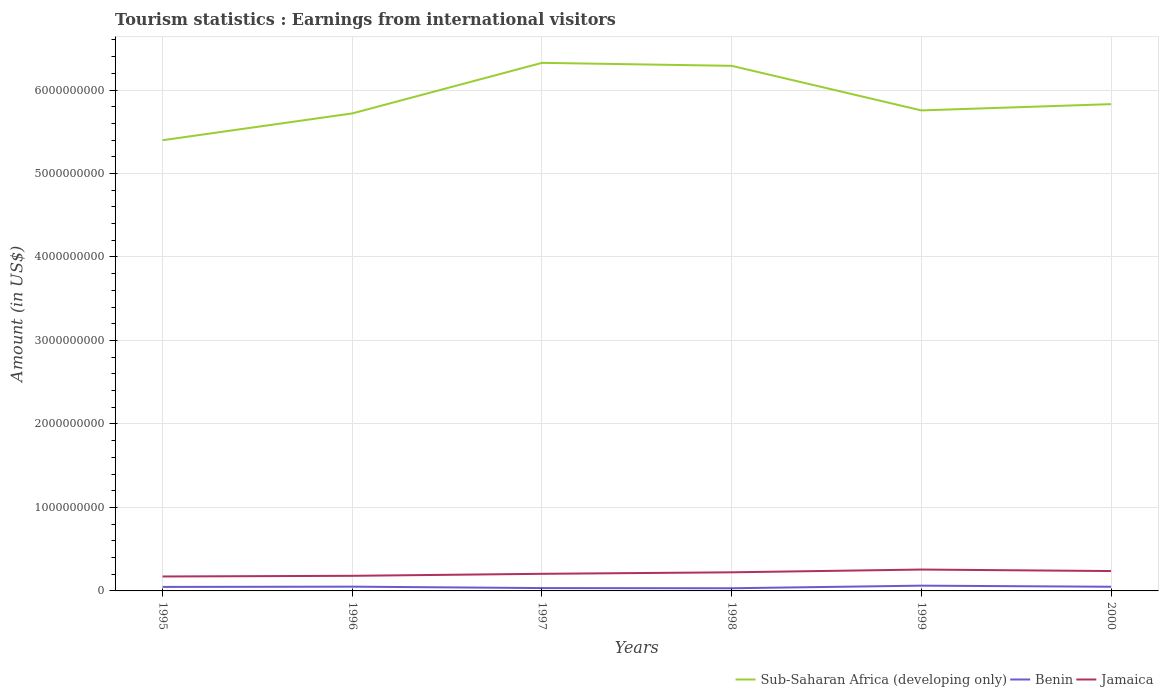Across all years, what is the maximum earnings from international visitors in Sub-Saharan Africa (developing only)?
Make the answer very short. 5.40e+09. What is the total earnings from international visitors in Sub-Saharan Africa (developing only) in the graph?
Provide a succinct answer. -6.06e+08. What is the difference between the highest and the second highest earnings from international visitors in Benin?
Offer a terse response. 3.10e+07. How many years are there in the graph?
Make the answer very short. 6. Does the graph contain grids?
Provide a short and direct response. Yes. What is the title of the graph?
Ensure brevity in your answer.  Tourism statistics : Earnings from international visitors. What is the label or title of the X-axis?
Your response must be concise. Years. What is the Amount (in US$) in Sub-Saharan Africa (developing only) in 1995?
Give a very brief answer. 5.40e+09. What is the Amount (in US$) of Benin in 1995?
Ensure brevity in your answer.  4.80e+07. What is the Amount (in US$) of Jamaica in 1995?
Your answer should be compact. 1.73e+08. What is the Amount (in US$) of Sub-Saharan Africa (developing only) in 1996?
Provide a short and direct response. 5.72e+09. What is the Amount (in US$) in Benin in 1996?
Your answer should be compact. 5.10e+07. What is the Amount (in US$) of Jamaica in 1996?
Your answer should be very brief. 1.81e+08. What is the Amount (in US$) of Sub-Saharan Africa (developing only) in 1997?
Give a very brief answer. 6.33e+09. What is the Amount (in US$) of Benin in 1997?
Your answer should be compact. 3.40e+07. What is the Amount (in US$) of Jamaica in 1997?
Make the answer very short. 2.05e+08. What is the Amount (in US$) of Sub-Saharan Africa (developing only) in 1998?
Your answer should be very brief. 6.29e+09. What is the Amount (in US$) of Benin in 1998?
Your answer should be compact. 3.20e+07. What is the Amount (in US$) of Jamaica in 1998?
Provide a succinct answer. 2.23e+08. What is the Amount (in US$) in Sub-Saharan Africa (developing only) in 1999?
Your answer should be compact. 5.76e+09. What is the Amount (in US$) in Benin in 1999?
Your response must be concise. 6.30e+07. What is the Amount (in US$) of Jamaica in 1999?
Offer a terse response. 2.56e+08. What is the Amount (in US$) of Sub-Saharan Africa (developing only) in 2000?
Offer a terse response. 5.83e+09. What is the Amount (in US$) of Benin in 2000?
Keep it short and to the point. 5.00e+07. What is the Amount (in US$) of Jamaica in 2000?
Provide a short and direct response. 2.38e+08. Across all years, what is the maximum Amount (in US$) in Sub-Saharan Africa (developing only)?
Your response must be concise. 6.33e+09. Across all years, what is the maximum Amount (in US$) in Benin?
Offer a terse response. 6.30e+07. Across all years, what is the maximum Amount (in US$) in Jamaica?
Your response must be concise. 2.56e+08. Across all years, what is the minimum Amount (in US$) in Sub-Saharan Africa (developing only)?
Your answer should be very brief. 5.40e+09. Across all years, what is the minimum Amount (in US$) of Benin?
Your answer should be compact. 3.20e+07. Across all years, what is the minimum Amount (in US$) of Jamaica?
Your answer should be compact. 1.73e+08. What is the total Amount (in US$) in Sub-Saharan Africa (developing only) in the graph?
Offer a very short reply. 3.53e+1. What is the total Amount (in US$) of Benin in the graph?
Give a very brief answer. 2.78e+08. What is the total Amount (in US$) of Jamaica in the graph?
Your response must be concise. 1.28e+09. What is the difference between the Amount (in US$) of Sub-Saharan Africa (developing only) in 1995 and that in 1996?
Offer a very short reply. -3.21e+08. What is the difference between the Amount (in US$) of Benin in 1995 and that in 1996?
Keep it short and to the point. -3.00e+06. What is the difference between the Amount (in US$) in Jamaica in 1995 and that in 1996?
Your response must be concise. -8.00e+06. What is the difference between the Amount (in US$) in Sub-Saharan Africa (developing only) in 1995 and that in 1997?
Make the answer very short. -9.27e+08. What is the difference between the Amount (in US$) of Benin in 1995 and that in 1997?
Offer a terse response. 1.40e+07. What is the difference between the Amount (in US$) of Jamaica in 1995 and that in 1997?
Your response must be concise. -3.20e+07. What is the difference between the Amount (in US$) of Sub-Saharan Africa (developing only) in 1995 and that in 1998?
Give a very brief answer. -8.91e+08. What is the difference between the Amount (in US$) in Benin in 1995 and that in 1998?
Keep it short and to the point. 1.60e+07. What is the difference between the Amount (in US$) in Jamaica in 1995 and that in 1998?
Give a very brief answer. -5.00e+07. What is the difference between the Amount (in US$) in Sub-Saharan Africa (developing only) in 1995 and that in 1999?
Provide a succinct answer. -3.57e+08. What is the difference between the Amount (in US$) of Benin in 1995 and that in 1999?
Make the answer very short. -1.50e+07. What is the difference between the Amount (in US$) in Jamaica in 1995 and that in 1999?
Your answer should be compact. -8.30e+07. What is the difference between the Amount (in US$) in Sub-Saharan Africa (developing only) in 1995 and that in 2000?
Your answer should be compact. -4.32e+08. What is the difference between the Amount (in US$) of Benin in 1995 and that in 2000?
Ensure brevity in your answer.  -2.00e+06. What is the difference between the Amount (in US$) of Jamaica in 1995 and that in 2000?
Keep it short and to the point. -6.50e+07. What is the difference between the Amount (in US$) of Sub-Saharan Africa (developing only) in 1996 and that in 1997?
Your answer should be compact. -6.06e+08. What is the difference between the Amount (in US$) in Benin in 1996 and that in 1997?
Ensure brevity in your answer.  1.70e+07. What is the difference between the Amount (in US$) of Jamaica in 1996 and that in 1997?
Your answer should be compact. -2.40e+07. What is the difference between the Amount (in US$) of Sub-Saharan Africa (developing only) in 1996 and that in 1998?
Give a very brief answer. -5.70e+08. What is the difference between the Amount (in US$) of Benin in 1996 and that in 1998?
Give a very brief answer. 1.90e+07. What is the difference between the Amount (in US$) in Jamaica in 1996 and that in 1998?
Offer a terse response. -4.20e+07. What is the difference between the Amount (in US$) in Sub-Saharan Africa (developing only) in 1996 and that in 1999?
Your answer should be compact. -3.59e+07. What is the difference between the Amount (in US$) of Benin in 1996 and that in 1999?
Provide a succinct answer. -1.20e+07. What is the difference between the Amount (in US$) of Jamaica in 1996 and that in 1999?
Your answer should be compact. -7.50e+07. What is the difference between the Amount (in US$) in Sub-Saharan Africa (developing only) in 1996 and that in 2000?
Give a very brief answer. -1.11e+08. What is the difference between the Amount (in US$) of Benin in 1996 and that in 2000?
Offer a terse response. 1.00e+06. What is the difference between the Amount (in US$) of Jamaica in 1996 and that in 2000?
Offer a very short reply. -5.70e+07. What is the difference between the Amount (in US$) in Sub-Saharan Africa (developing only) in 1997 and that in 1998?
Provide a succinct answer. 3.57e+07. What is the difference between the Amount (in US$) of Benin in 1997 and that in 1998?
Ensure brevity in your answer.  2.00e+06. What is the difference between the Amount (in US$) of Jamaica in 1997 and that in 1998?
Give a very brief answer. -1.80e+07. What is the difference between the Amount (in US$) of Sub-Saharan Africa (developing only) in 1997 and that in 1999?
Offer a terse response. 5.70e+08. What is the difference between the Amount (in US$) in Benin in 1997 and that in 1999?
Offer a terse response. -2.90e+07. What is the difference between the Amount (in US$) in Jamaica in 1997 and that in 1999?
Keep it short and to the point. -5.10e+07. What is the difference between the Amount (in US$) of Sub-Saharan Africa (developing only) in 1997 and that in 2000?
Your response must be concise. 4.95e+08. What is the difference between the Amount (in US$) in Benin in 1997 and that in 2000?
Give a very brief answer. -1.60e+07. What is the difference between the Amount (in US$) of Jamaica in 1997 and that in 2000?
Offer a terse response. -3.30e+07. What is the difference between the Amount (in US$) of Sub-Saharan Africa (developing only) in 1998 and that in 1999?
Offer a terse response. 5.34e+08. What is the difference between the Amount (in US$) in Benin in 1998 and that in 1999?
Provide a short and direct response. -3.10e+07. What is the difference between the Amount (in US$) in Jamaica in 1998 and that in 1999?
Your answer should be very brief. -3.30e+07. What is the difference between the Amount (in US$) in Sub-Saharan Africa (developing only) in 1998 and that in 2000?
Keep it short and to the point. 4.59e+08. What is the difference between the Amount (in US$) of Benin in 1998 and that in 2000?
Offer a very short reply. -1.80e+07. What is the difference between the Amount (in US$) in Jamaica in 1998 and that in 2000?
Keep it short and to the point. -1.50e+07. What is the difference between the Amount (in US$) in Sub-Saharan Africa (developing only) in 1999 and that in 2000?
Make the answer very short. -7.52e+07. What is the difference between the Amount (in US$) in Benin in 1999 and that in 2000?
Keep it short and to the point. 1.30e+07. What is the difference between the Amount (in US$) in Jamaica in 1999 and that in 2000?
Provide a succinct answer. 1.80e+07. What is the difference between the Amount (in US$) of Sub-Saharan Africa (developing only) in 1995 and the Amount (in US$) of Benin in 1996?
Offer a very short reply. 5.35e+09. What is the difference between the Amount (in US$) of Sub-Saharan Africa (developing only) in 1995 and the Amount (in US$) of Jamaica in 1996?
Give a very brief answer. 5.22e+09. What is the difference between the Amount (in US$) in Benin in 1995 and the Amount (in US$) in Jamaica in 1996?
Your answer should be very brief. -1.33e+08. What is the difference between the Amount (in US$) in Sub-Saharan Africa (developing only) in 1995 and the Amount (in US$) in Benin in 1997?
Your response must be concise. 5.36e+09. What is the difference between the Amount (in US$) in Sub-Saharan Africa (developing only) in 1995 and the Amount (in US$) in Jamaica in 1997?
Offer a terse response. 5.19e+09. What is the difference between the Amount (in US$) of Benin in 1995 and the Amount (in US$) of Jamaica in 1997?
Your answer should be compact. -1.57e+08. What is the difference between the Amount (in US$) in Sub-Saharan Africa (developing only) in 1995 and the Amount (in US$) in Benin in 1998?
Your response must be concise. 5.37e+09. What is the difference between the Amount (in US$) in Sub-Saharan Africa (developing only) in 1995 and the Amount (in US$) in Jamaica in 1998?
Your answer should be compact. 5.18e+09. What is the difference between the Amount (in US$) in Benin in 1995 and the Amount (in US$) in Jamaica in 1998?
Provide a succinct answer. -1.75e+08. What is the difference between the Amount (in US$) in Sub-Saharan Africa (developing only) in 1995 and the Amount (in US$) in Benin in 1999?
Offer a terse response. 5.34e+09. What is the difference between the Amount (in US$) of Sub-Saharan Africa (developing only) in 1995 and the Amount (in US$) of Jamaica in 1999?
Keep it short and to the point. 5.14e+09. What is the difference between the Amount (in US$) in Benin in 1995 and the Amount (in US$) in Jamaica in 1999?
Your response must be concise. -2.08e+08. What is the difference between the Amount (in US$) of Sub-Saharan Africa (developing only) in 1995 and the Amount (in US$) of Benin in 2000?
Offer a terse response. 5.35e+09. What is the difference between the Amount (in US$) of Sub-Saharan Africa (developing only) in 1995 and the Amount (in US$) of Jamaica in 2000?
Make the answer very short. 5.16e+09. What is the difference between the Amount (in US$) of Benin in 1995 and the Amount (in US$) of Jamaica in 2000?
Your response must be concise. -1.90e+08. What is the difference between the Amount (in US$) in Sub-Saharan Africa (developing only) in 1996 and the Amount (in US$) in Benin in 1997?
Give a very brief answer. 5.69e+09. What is the difference between the Amount (in US$) of Sub-Saharan Africa (developing only) in 1996 and the Amount (in US$) of Jamaica in 1997?
Offer a terse response. 5.51e+09. What is the difference between the Amount (in US$) in Benin in 1996 and the Amount (in US$) in Jamaica in 1997?
Offer a very short reply. -1.54e+08. What is the difference between the Amount (in US$) of Sub-Saharan Africa (developing only) in 1996 and the Amount (in US$) of Benin in 1998?
Make the answer very short. 5.69e+09. What is the difference between the Amount (in US$) in Sub-Saharan Africa (developing only) in 1996 and the Amount (in US$) in Jamaica in 1998?
Give a very brief answer. 5.50e+09. What is the difference between the Amount (in US$) in Benin in 1996 and the Amount (in US$) in Jamaica in 1998?
Your answer should be very brief. -1.72e+08. What is the difference between the Amount (in US$) in Sub-Saharan Africa (developing only) in 1996 and the Amount (in US$) in Benin in 1999?
Your response must be concise. 5.66e+09. What is the difference between the Amount (in US$) of Sub-Saharan Africa (developing only) in 1996 and the Amount (in US$) of Jamaica in 1999?
Your answer should be compact. 5.46e+09. What is the difference between the Amount (in US$) in Benin in 1996 and the Amount (in US$) in Jamaica in 1999?
Offer a very short reply. -2.05e+08. What is the difference between the Amount (in US$) in Sub-Saharan Africa (developing only) in 1996 and the Amount (in US$) in Benin in 2000?
Your answer should be compact. 5.67e+09. What is the difference between the Amount (in US$) of Sub-Saharan Africa (developing only) in 1996 and the Amount (in US$) of Jamaica in 2000?
Your answer should be compact. 5.48e+09. What is the difference between the Amount (in US$) in Benin in 1996 and the Amount (in US$) in Jamaica in 2000?
Your answer should be very brief. -1.87e+08. What is the difference between the Amount (in US$) in Sub-Saharan Africa (developing only) in 1997 and the Amount (in US$) in Benin in 1998?
Give a very brief answer. 6.29e+09. What is the difference between the Amount (in US$) of Sub-Saharan Africa (developing only) in 1997 and the Amount (in US$) of Jamaica in 1998?
Ensure brevity in your answer.  6.10e+09. What is the difference between the Amount (in US$) in Benin in 1997 and the Amount (in US$) in Jamaica in 1998?
Ensure brevity in your answer.  -1.89e+08. What is the difference between the Amount (in US$) in Sub-Saharan Africa (developing only) in 1997 and the Amount (in US$) in Benin in 1999?
Provide a succinct answer. 6.26e+09. What is the difference between the Amount (in US$) in Sub-Saharan Africa (developing only) in 1997 and the Amount (in US$) in Jamaica in 1999?
Ensure brevity in your answer.  6.07e+09. What is the difference between the Amount (in US$) of Benin in 1997 and the Amount (in US$) of Jamaica in 1999?
Keep it short and to the point. -2.22e+08. What is the difference between the Amount (in US$) in Sub-Saharan Africa (developing only) in 1997 and the Amount (in US$) in Benin in 2000?
Your response must be concise. 6.28e+09. What is the difference between the Amount (in US$) in Sub-Saharan Africa (developing only) in 1997 and the Amount (in US$) in Jamaica in 2000?
Your answer should be compact. 6.09e+09. What is the difference between the Amount (in US$) in Benin in 1997 and the Amount (in US$) in Jamaica in 2000?
Give a very brief answer. -2.04e+08. What is the difference between the Amount (in US$) of Sub-Saharan Africa (developing only) in 1998 and the Amount (in US$) of Benin in 1999?
Keep it short and to the point. 6.23e+09. What is the difference between the Amount (in US$) of Sub-Saharan Africa (developing only) in 1998 and the Amount (in US$) of Jamaica in 1999?
Provide a short and direct response. 6.03e+09. What is the difference between the Amount (in US$) of Benin in 1998 and the Amount (in US$) of Jamaica in 1999?
Keep it short and to the point. -2.24e+08. What is the difference between the Amount (in US$) of Sub-Saharan Africa (developing only) in 1998 and the Amount (in US$) of Benin in 2000?
Offer a terse response. 6.24e+09. What is the difference between the Amount (in US$) in Sub-Saharan Africa (developing only) in 1998 and the Amount (in US$) in Jamaica in 2000?
Make the answer very short. 6.05e+09. What is the difference between the Amount (in US$) in Benin in 1998 and the Amount (in US$) in Jamaica in 2000?
Your answer should be compact. -2.06e+08. What is the difference between the Amount (in US$) in Sub-Saharan Africa (developing only) in 1999 and the Amount (in US$) in Benin in 2000?
Offer a very short reply. 5.71e+09. What is the difference between the Amount (in US$) of Sub-Saharan Africa (developing only) in 1999 and the Amount (in US$) of Jamaica in 2000?
Keep it short and to the point. 5.52e+09. What is the difference between the Amount (in US$) in Benin in 1999 and the Amount (in US$) in Jamaica in 2000?
Offer a very short reply. -1.75e+08. What is the average Amount (in US$) in Sub-Saharan Africa (developing only) per year?
Give a very brief answer. 5.89e+09. What is the average Amount (in US$) in Benin per year?
Ensure brevity in your answer.  4.63e+07. What is the average Amount (in US$) of Jamaica per year?
Offer a very short reply. 2.13e+08. In the year 1995, what is the difference between the Amount (in US$) of Sub-Saharan Africa (developing only) and Amount (in US$) of Benin?
Offer a very short reply. 5.35e+09. In the year 1995, what is the difference between the Amount (in US$) in Sub-Saharan Africa (developing only) and Amount (in US$) in Jamaica?
Your answer should be very brief. 5.23e+09. In the year 1995, what is the difference between the Amount (in US$) of Benin and Amount (in US$) of Jamaica?
Keep it short and to the point. -1.25e+08. In the year 1996, what is the difference between the Amount (in US$) in Sub-Saharan Africa (developing only) and Amount (in US$) in Benin?
Your answer should be compact. 5.67e+09. In the year 1996, what is the difference between the Amount (in US$) in Sub-Saharan Africa (developing only) and Amount (in US$) in Jamaica?
Offer a very short reply. 5.54e+09. In the year 1996, what is the difference between the Amount (in US$) in Benin and Amount (in US$) in Jamaica?
Make the answer very short. -1.30e+08. In the year 1997, what is the difference between the Amount (in US$) of Sub-Saharan Africa (developing only) and Amount (in US$) of Benin?
Provide a short and direct response. 6.29e+09. In the year 1997, what is the difference between the Amount (in US$) in Sub-Saharan Africa (developing only) and Amount (in US$) in Jamaica?
Offer a terse response. 6.12e+09. In the year 1997, what is the difference between the Amount (in US$) of Benin and Amount (in US$) of Jamaica?
Offer a terse response. -1.71e+08. In the year 1998, what is the difference between the Amount (in US$) of Sub-Saharan Africa (developing only) and Amount (in US$) of Benin?
Ensure brevity in your answer.  6.26e+09. In the year 1998, what is the difference between the Amount (in US$) in Sub-Saharan Africa (developing only) and Amount (in US$) in Jamaica?
Make the answer very short. 6.07e+09. In the year 1998, what is the difference between the Amount (in US$) of Benin and Amount (in US$) of Jamaica?
Offer a very short reply. -1.91e+08. In the year 1999, what is the difference between the Amount (in US$) of Sub-Saharan Africa (developing only) and Amount (in US$) of Benin?
Your response must be concise. 5.69e+09. In the year 1999, what is the difference between the Amount (in US$) of Sub-Saharan Africa (developing only) and Amount (in US$) of Jamaica?
Your answer should be compact. 5.50e+09. In the year 1999, what is the difference between the Amount (in US$) in Benin and Amount (in US$) in Jamaica?
Keep it short and to the point. -1.93e+08. In the year 2000, what is the difference between the Amount (in US$) of Sub-Saharan Africa (developing only) and Amount (in US$) of Benin?
Keep it short and to the point. 5.78e+09. In the year 2000, what is the difference between the Amount (in US$) in Sub-Saharan Africa (developing only) and Amount (in US$) in Jamaica?
Your answer should be very brief. 5.59e+09. In the year 2000, what is the difference between the Amount (in US$) in Benin and Amount (in US$) in Jamaica?
Offer a terse response. -1.88e+08. What is the ratio of the Amount (in US$) in Sub-Saharan Africa (developing only) in 1995 to that in 1996?
Your answer should be very brief. 0.94. What is the ratio of the Amount (in US$) of Jamaica in 1995 to that in 1996?
Keep it short and to the point. 0.96. What is the ratio of the Amount (in US$) in Sub-Saharan Africa (developing only) in 1995 to that in 1997?
Provide a succinct answer. 0.85. What is the ratio of the Amount (in US$) of Benin in 1995 to that in 1997?
Offer a very short reply. 1.41. What is the ratio of the Amount (in US$) in Jamaica in 1995 to that in 1997?
Your response must be concise. 0.84. What is the ratio of the Amount (in US$) of Sub-Saharan Africa (developing only) in 1995 to that in 1998?
Provide a short and direct response. 0.86. What is the ratio of the Amount (in US$) in Jamaica in 1995 to that in 1998?
Provide a succinct answer. 0.78. What is the ratio of the Amount (in US$) in Sub-Saharan Africa (developing only) in 1995 to that in 1999?
Your answer should be compact. 0.94. What is the ratio of the Amount (in US$) in Benin in 1995 to that in 1999?
Keep it short and to the point. 0.76. What is the ratio of the Amount (in US$) of Jamaica in 1995 to that in 1999?
Offer a very short reply. 0.68. What is the ratio of the Amount (in US$) of Sub-Saharan Africa (developing only) in 1995 to that in 2000?
Your answer should be very brief. 0.93. What is the ratio of the Amount (in US$) of Jamaica in 1995 to that in 2000?
Provide a succinct answer. 0.73. What is the ratio of the Amount (in US$) in Sub-Saharan Africa (developing only) in 1996 to that in 1997?
Your answer should be very brief. 0.9. What is the ratio of the Amount (in US$) of Benin in 1996 to that in 1997?
Provide a short and direct response. 1.5. What is the ratio of the Amount (in US$) in Jamaica in 1996 to that in 1997?
Provide a short and direct response. 0.88. What is the ratio of the Amount (in US$) in Sub-Saharan Africa (developing only) in 1996 to that in 1998?
Provide a short and direct response. 0.91. What is the ratio of the Amount (in US$) of Benin in 1996 to that in 1998?
Your answer should be very brief. 1.59. What is the ratio of the Amount (in US$) in Jamaica in 1996 to that in 1998?
Make the answer very short. 0.81. What is the ratio of the Amount (in US$) in Benin in 1996 to that in 1999?
Your response must be concise. 0.81. What is the ratio of the Amount (in US$) in Jamaica in 1996 to that in 1999?
Offer a very short reply. 0.71. What is the ratio of the Amount (in US$) in Sub-Saharan Africa (developing only) in 1996 to that in 2000?
Keep it short and to the point. 0.98. What is the ratio of the Amount (in US$) of Jamaica in 1996 to that in 2000?
Give a very brief answer. 0.76. What is the ratio of the Amount (in US$) of Jamaica in 1997 to that in 1998?
Keep it short and to the point. 0.92. What is the ratio of the Amount (in US$) in Sub-Saharan Africa (developing only) in 1997 to that in 1999?
Your answer should be very brief. 1.1. What is the ratio of the Amount (in US$) of Benin in 1997 to that in 1999?
Make the answer very short. 0.54. What is the ratio of the Amount (in US$) of Jamaica in 1997 to that in 1999?
Your answer should be compact. 0.8. What is the ratio of the Amount (in US$) of Sub-Saharan Africa (developing only) in 1997 to that in 2000?
Ensure brevity in your answer.  1.08. What is the ratio of the Amount (in US$) in Benin in 1997 to that in 2000?
Provide a short and direct response. 0.68. What is the ratio of the Amount (in US$) in Jamaica in 1997 to that in 2000?
Your response must be concise. 0.86. What is the ratio of the Amount (in US$) in Sub-Saharan Africa (developing only) in 1998 to that in 1999?
Keep it short and to the point. 1.09. What is the ratio of the Amount (in US$) of Benin in 1998 to that in 1999?
Make the answer very short. 0.51. What is the ratio of the Amount (in US$) of Jamaica in 1998 to that in 1999?
Your response must be concise. 0.87. What is the ratio of the Amount (in US$) in Sub-Saharan Africa (developing only) in 1998 to that in 2000?
Keep it short and to the point. 1.08. What is the ratio of the Amount (in US$) of Benin in 1998 to that in 2000?
Offer a terse response. 0.64. What is the ratio of the Amount (in US$) of Jamaica in 1998 to that in 2000?
Offer a very short reply. 0.94. What is the ratio of the Amount (in US$) of Sub-Saharan Africa (developing only) in 1999 to that in 2000?
Your answer should be very brief. 0.99. What is the ratio of the Amount (in US$) of Benin in 1999 to that in 2000?
Provide a succinct answer. 1.26. What is the ratio of the Amount (in US$) in Jamaica in 1999 to that in 2000?
Your response must be concise. 1.08. What is the difference between the highest and the second highest Amount (in US$) in Sub-Saharan Africa (developing only)?
Give a very brief answer. 3.57e+07. What is the difference between the highest and the second highest Amount (in US$) of Benin?
Make the answer very short. 1.20e+07. What is the difference between the highest and the second highest Amount (in US$) in Jamaica?
Give a very brief answer. 1.80e+07. What is the difference between the highest and the lowest Amount (in US$) in Sub-Saharan Africa (developing only)?
Provide a short and direct response. 9.27e+08. What is the difference between the highest and the lowest Amount (in US$) of Benin?
Provide a succinct answer. 3.10e+07. What is the difference between the highest and the lowest Amount (in US$) in Jamaica?
Make the answer very short. 8.30e+07. 